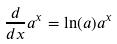<formula> <loc_0><loc_0><loc_500><loc_500>\frac { d } { d x } a ^ { x } = \ln ( a ) a ^ { x }</formula> 